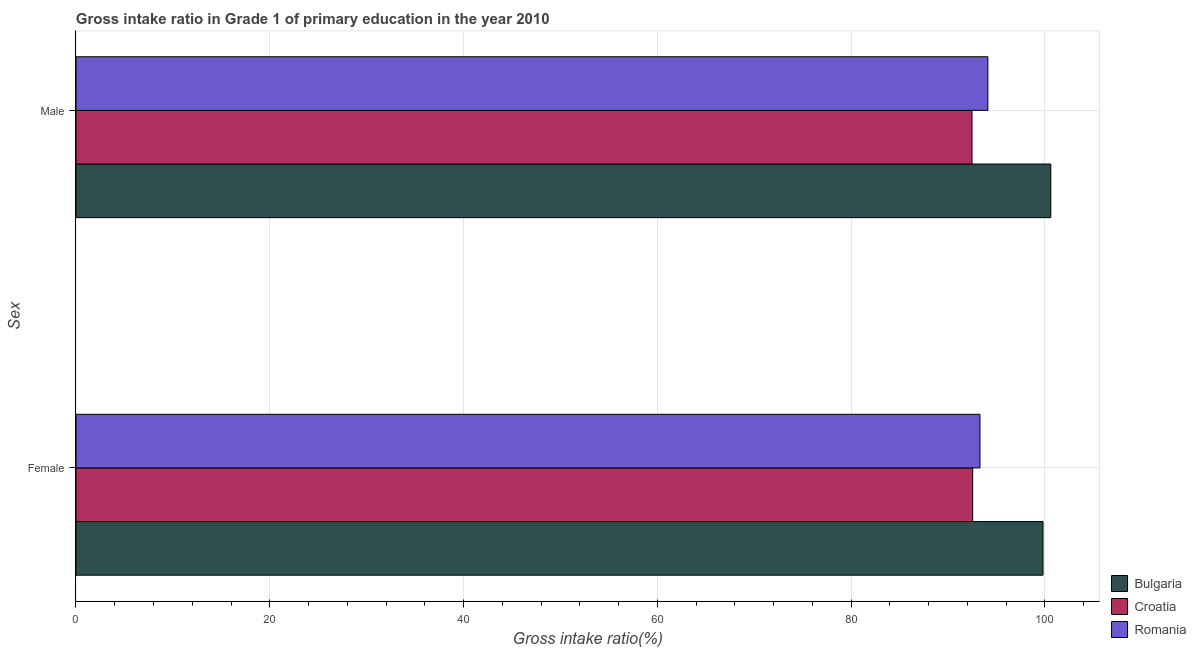How many groups of bars are there?
Your answer should be very brief. 2. How many bars are there on the 2nd tick from the top?
Your response must be concise. 3. How many bars are there on the 2nd tick from the bottom?
Your answer should be very brief. 3. What is the gross intake ratio(male) in Romania?
Ensure brevity in your answer.  94.13. Across all countries, what is the maximum gross intake ratio(male)?
Offer a terse response. 100.62. Across all countries, what is the minimum gross intake ratio(male)?
Your answer should be compact. 92.49. In which country was the gross intake ratio(male) minimum?
Offer a terse response. Croatia. What is the total gross intake ratio(female) in the graph?
Provide a short and direct response. 285.68. What is the difference between the gross intake ratio(male) in Croatia and that in Romania?
Provide a short and direct response. -1.64. What is the difference between the gross intake ratio(male) in Bulgaria and the gross intake ratio(female) in Croatia?
Keep it short and to the point. 8.06. What is the average gross intake ratio(female) per country?
Make the answer very short. 95.23. What is the difference between the gross intake ratio(male) and gross intake ratio(female) in Croatia?
Keep it short and to the point. -0.07. What is the ratio of the gross intake ratio(female) in Bulgaria to that in Romania?
Your answer should be compact. 1.07. What does the 2nd bar from the top in Female represents?
Keep it short and to the point. Croatia. Are all the bars in the graph horizontal?
Offer a terse response. Yes. How many countries are there in the graph?
Your response must be concise. 3. Does the graph contain any zero values?
Keep it short and to the point. No. Where does the legend appear in the graph?
Offer a very short reply. Bottom right. How many legend labels are there?
Ensure brevity in your answer.  3. What is the title of the graph?
Provide a succinct answer. Gross intake ratio in Grade 1 of primary education in the year 2010. What is the label or title of the X-axis?
Provide a short and direct response. Gross intake ratio(%). What is the label or title of the Y-axis?
Your answer should be compact. Sex. What is the Gross intake ratio(%) in Bulgaria in Female?
Offer a terse response. 99.82. What is the Gross intake ratio(%) in Croatia in Female?
Make the answer very short. 92.56. What is the Gross intake ratio(%) of Romania in Female?
Offer a terse response. 93.31. What is the Gross intake ratio(%) in Bulgaria in Male?
Your response must be concise. 100.62. What is the Gross intake ratio(%) in Croatia in Male?
Make the answer very short. 92.49. What is the Gross intake ratio(%) in Romania in Male?
Your response must be concise. 94.13. Across all Sex, what is the maximum Gross intake ratio(%) in Bulgaria?
Your answer should be very brief. 100.62. Across all Sex, what is the maximum Gross intake ratio(%) of Croatia?
Your response must be concise. 92.56. Across all Sex, what is the maximum Gross intake ratio(%) of Romania?
Your answer should be very brief. 94.13. Across all Sex, what is the minimum Gross intake ratio(%) of Bulgaria?
Offer a very short reply. 99.82. Across all Sex, what is the minimum Gross intake ratio(%) of Croatia?
Provide a succinct answer. 92.49. Across all Sex, what is the minimum Gross intake ratio(%) of Romania?
Provide a short and direct response. 93.31. What is the total Gross intake ratio(%) of Bulgaria in the graph?
Provide a succinct answer. 200.44. What is the total Gross intake ratio(%) in Croatia in the graph?
Offer a very short reply. 185.04. What is the total Gross intake ratio(%) in Romania in the graph?
Your answer should be compact. 187.43. What is the difference between the Gross intake ratio(%) of Bulgaria in Female and that in Male?
Your response must be concise. -0.8. What is the difference between the Gross intake ratio(%) of Croatia in Female and that in Male?
Your answer should be very brief. 0.07. What is the difference between the Gross intake ratio(%) in Romania in Female and that in Male?
Your answer should be compact. -0.82. What is the difference between the Gross intake ratio(%) in Bulgaria in Female and the Gross intake ratio(%) in Croatia in Male?
Ensure brevity in your answer.  7.33. What is the difference between the Gross intake ratio(%) of Bulgaria in Female and the Gross intake ratio(%) of Romania in Male?
Provide a short and direct response. 5.69. What is the difference between the Gross intake ratio(%) of Croatia in Female and the Gross intake ratio(%) of Romania in Male?
Make the answer very short. -1.57. What is the average Gross intake ratio(%) in Bulgaria per Sex?
Your answer should be very brief. 100.22. What is the average Gross intake ratio(%) of Croatia per Sex?
Ensure brevity in your answer.  92.52. What is the average Gross intake ratio(%) of Romania per Sex?
Provide a short and direct response. 93.72. What is the difference between the Gross intake ratio(%) of Bulgaria and Gross intake ratio(%) of Croatia in Female?
Offer a very short reply. 7.26. What is the difference between the Gross intake ratio(%) in Bulgaria and Gross intake ratio(%) in Romania in Female?
Ensure brevity in your answer.  6.51. What is the difference between the Gross intake ratio(%) in Croatia and Gross intake ratio(%) in Romania in Female?
Offer a very short reply. -0.75. What is the difference between the Gross intake ratio(%) of Bulgaria and Gross intake ratio(%) of Croatia in Male?
Your answer should be very brief. 8.13. What is the difference between the Gross intake ratio(%) in Bulgaria and Gross intake ratio(%) in Romania in Male?
Give a very brief answer. 6.49. What is the difference between the Gross intake ratio(%) in Croatia and Gross intake ratio(%) in Romania in Male?
Offer a terse response. -1.64. What is the ratio of the Gross intake ratio(%) of Bulgaria in Female to that in Male?
Keep it short and to the point. 0.99. What is the ratio of the Gross intake ratio(%) of Croatia in Female to that in Male?
Ensure brevity in your answer.  1. What is the difference between the highest and the second highest Gross intake ratio(%) of Bulgaria?
Your answer should be compact. 0.8. What is the difference between the highest and the second highest Gross intake ratio(%) in Croatia?
Make the answer very short. 0.07. What is the difference between the highest and the second highest Gross intake ratio(%) of Romania?
Give a very brief answer. 0.82. What is the difference between the highest and the lowest Gross intake ratio(%) of Bulgaria?
Give a very brief answer. 0.8. What is the difference between the highest and the lowest Gross intake ratio(%) in Croatia?
Ensure brevity in your answer.  0.07. What is the difference between the highest and the lowest Gross intake ratio(%) of Romania?
Make the answer very short. 0.82. 